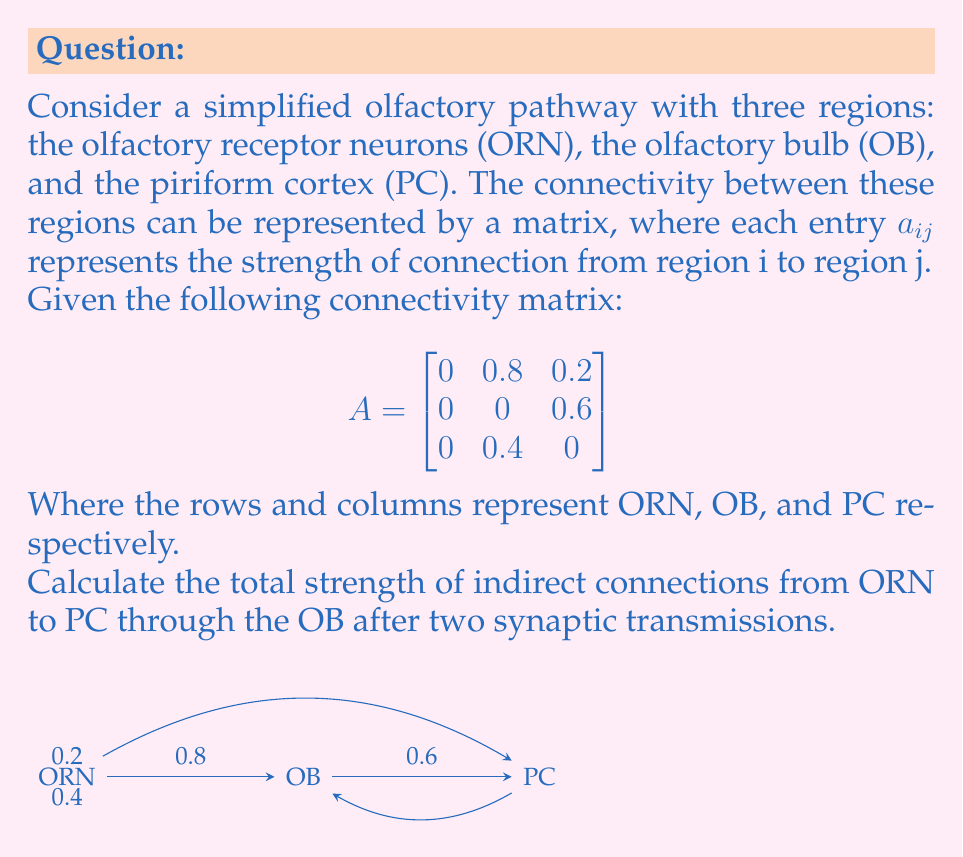Can you answer this question? To solve this problem, we need to understand matrix multiplication and its application to neural pathways:

1) The given matrix A represents direct connections between regions. To find connections after two synaptic transmissions, we need to calculate $A^2$.

2) In matrix multiplication, each element of $A^2$ is calculated as:

   $$(A^2)_{ij} = \sum_{k=1}^n a_{ik} a_{kj}$$

3) Let's calculate $A^2$:

   $$
   A^2 = \begin{bmatrix}
   0 & 0.8 & 0.2 \\
   0 & 0 & 0.6 \\
   0 & 0.4 & 0
   \end{bmatrix}
   \times
   \begin{bmatrix}
   0 & 0.8 & 0.2 \\
   0 & 0 & 0.6 \\
   0 & 0.4 & 0
   \end{bmatrix}
   $$

4) The element we're interested in is $(A^2)_{13}$, which represents the indirect connection from ORN to PC after two synapses:

   $$(A^2)_{13} = (0 \times 0) + (0.8 \times 0.6) + (0.2 \times 0) = 0.48$$

5) This value, 0.48, represents the total strength of indirect connections from ORN to PC through the OB after two synaptic transmissions.
Answer: 0.48 